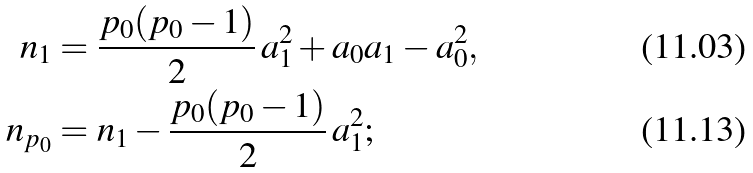<formula> <loc_0><loc_0><loc_500><loc_500>n _ { 1 } & = \frac { p _ { 0 } ( p _ { 0 } - 1 ) } 2 \, a _ { 1 } ^ { 2 } + a _ { 0 } a _ { 1 } - a _ { 0 } ^ { 2 } , \\ n _ { p _ { 0 } } & = n _ { 1 } - \frac { p _ { 0 } ( p _ { 0 } - 1 ) } 2 \, a _ { 1 } ^ { 2 } ;</formula> 